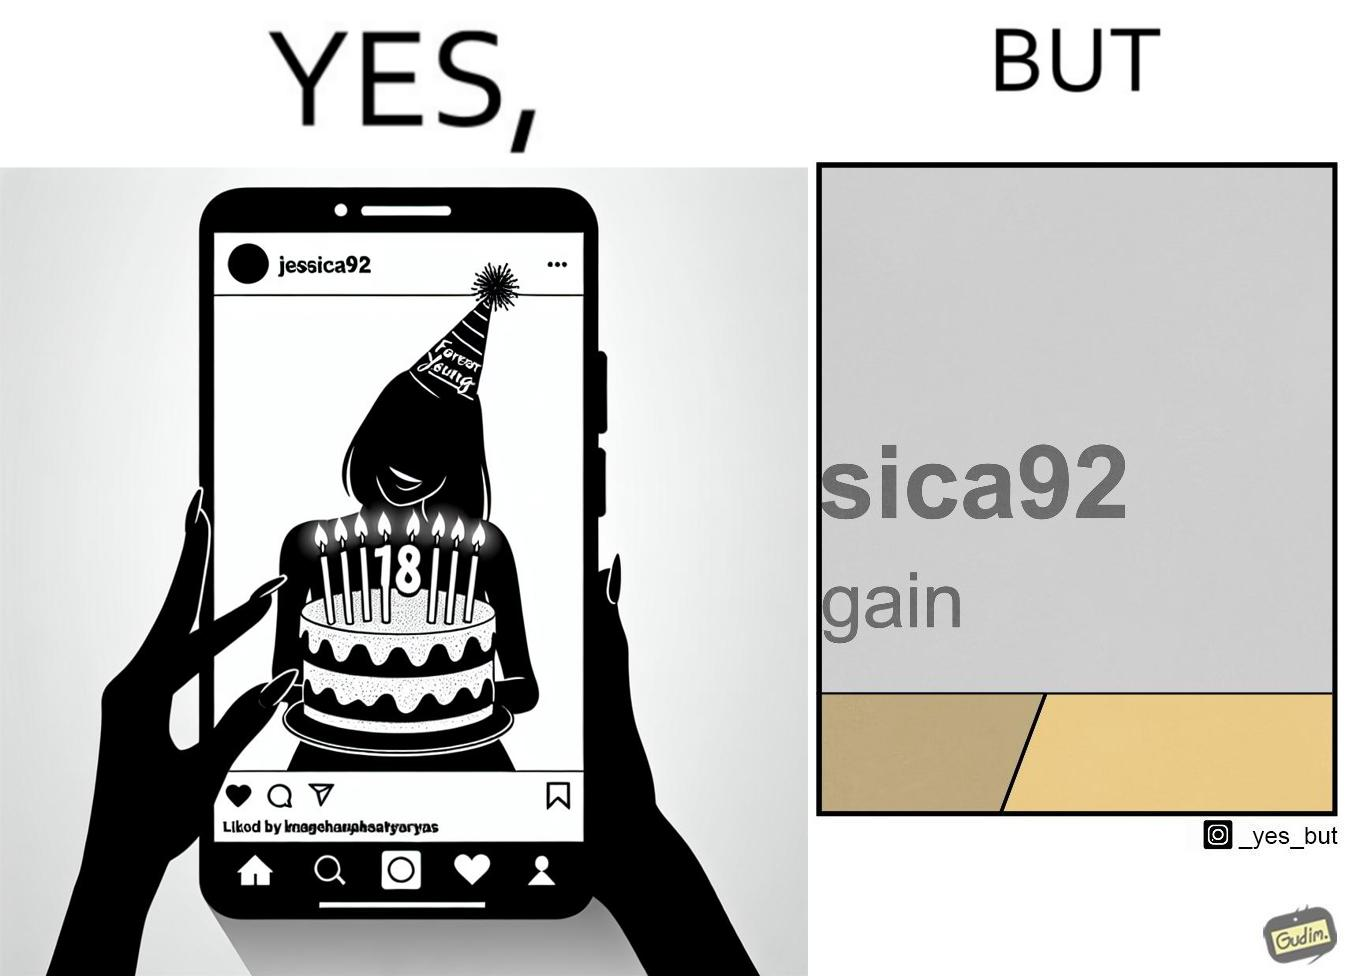Explain the humor or irony in this image. The image is funny because while the woman claims she to be young, the likely year of her birth 1992 which can be inferred from her handle "jessica92" suggests that she is very old. 